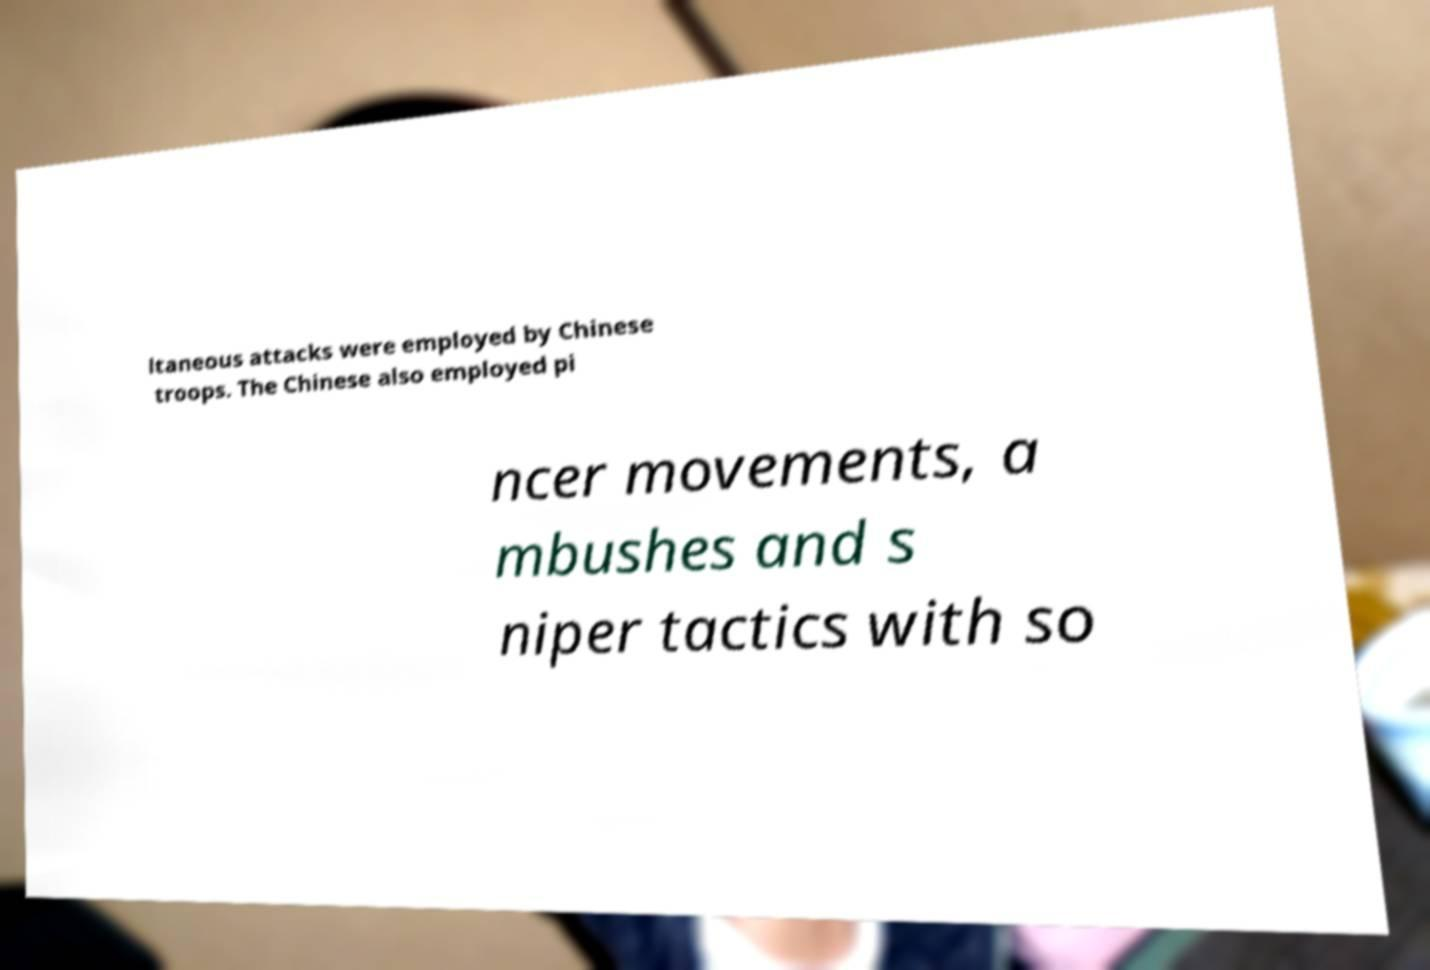Could you extract and type out the text from this image? ltaneous attacks were employed by Chinese troops. The Chinese also employed pi ncer movements, a mbushes and s niper tactics with so 